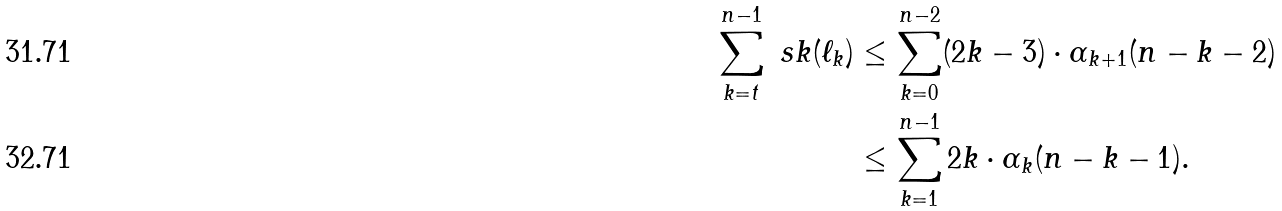<formula> <loc_0><loc_0><loc_500><loc_500>\sum _ { k = t } ^ { n - 1 } \ s k ( \ell _ { k } ) & \leq \sum _ { k = 0 } ^ { n - 2 } ( 2 k - 3 ) \cdot \alpha _ { k + 1 } ( n - k - 2 ) \\ & \leq \sum _ { k = 1 } ^ { n - 1 } 2 k \cdot \alpha _ { k } ( n - k - 1 ) .</formula> 